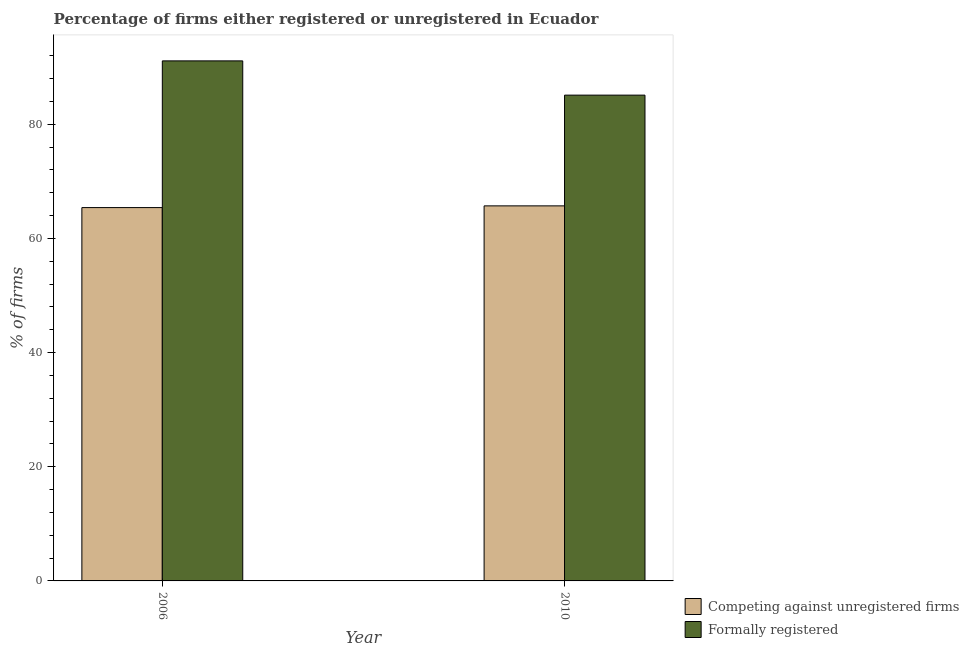How many groups of bars are there?
Keep it short and to the point. 2. How many bars are there on the 1st tick from the left?
Offer a very short reply. 2. How many bars are there on the 2nd tick from the right?
Give a very brief answer. 2. What is the label of the 1st group of bars from the left?
Your response must be concise. 2006. What is the percentage of registered firms in 2010?
Ensure brevity in your answer.  65.7. Across all years, what is the maximum percentage of registered firms?
Your answer should be very brief. 65.7. Across all years, what is the minimum percentage of formally registered firms?
Provide a succinct answer. 85.1. In which year was the percentage of registered firms minimum?
Give a very brief answer. 2006. What is the total percentage of formally registered firms in the graph?
Provide a short and direct response. 176.2. What is the difference between the percentage of registered firms in 2006 and that in 2010?
Give a very brief answer. -0.3. What is the difference between the percentage of registered firms in 2010 and the percentage of formally registered firms in 2006?
Your response must be concise. 0.3. What is the average percentage of registered firms per year?
Provide a succinct answer. 65.55. In the year 2010, what is the difference between the percentage of registered firms and percentage of formally registered firms?
Offer a very short reply. 0. What is the ratio of the percentage of registered firms in 2006 to that in 2010?
Your answer should be compact. 1. In how many years, is the percentage of formally registered firms greater than the average percentage of formally registered firms taken over all years?
Make the answer very short. 1. What does the 2nd bar from the left in 2006 represents?
Your response must be concise. Formally registered. What does the 2nd bar from the right in 2010 represents?
Make the answer very short. Competing against unregistered firms. How many bars are there?
Provide a short and direct response. 4. Are all the bars in the graph horizontal?
Make the answer very short. No. Are the values on the major ticks of Y-axis written in scientific E-notation?
Your response must be concise. No. Does the graph contain any zero values?
Provide a succinct answer. No. Does the graph contain grids?
Provide a succinct answer. No. How are the legend labels stacked?
Provide a short and direct response. Vertical. What is the title of the graph?
Your answer should be compact. Percentage of firms either registered or unregistered in Ecuador. What is the label or title of the Y-axis?
Give a very brief answer. % of firms. What is the % of firms in Competing against unregistered firms in 2006?
Your response must be concise. 65.4. What is the % of firms in Formally registered in 2006?
Give a very brief answer. 91.1. What is the % of firms in Competing against unregistered firms in 2010?
Provide a short and direct response. 65.7. What is the % of firms in Formally registered in 2010?
Your response must be concise. 85.1. Across all years, what is the maximum % of firms in Competing against unregistered firms?
Your answer should be compact. 65.7. Across all years, what is the maximum % of firms of Formally registered?
Ensure brevity in your answer.  91.1. Across all years, what is the minimum % of firms in Competing against unregistered firms?
Make the answer very short. 65.4. Across all years, what is the minimum % of firms in Formally registered?
Your answer should be compact. 85.1. What is the total % of firms in Competing against unregistered firms in the graph?
Make the answer very short. 131.1. What is the total % of firms of Formally registered in the graph?
Ensure brevity in your answer.  176.2. What is the difference between the % of firms of Competing against unregistered firms in 2006 and the % of firms of Formally registered in 2010?
Offer a very short reply. -19.7. What is the average % of firms in Competing against unregistered firms per year?
Offer a very short reply. 65.55. What is the average % of firms in Formally registered per year?
Give a very brief answer. 88.1. In the year 2006, what is the difference between the % of firms in Competing against unregistered firms and % of firms in Formally registered?
Your answer should be very brief. -25.7. In the year 2010, what is the difference between the % of firms in Competing against unregistered firms and % of firms in Formally registered?
Your answer should be very brief. -19.4. What is the ratio of the % of firms of Formally registered in 2006 to that in 2010?
Offer a very short reply. 1.07. What is the difference between the highest and the second highest % of firms in Formally registered?
Keep it short and to the point. 6. What is the difference between the highest and the lowest % of firms of Competing against unregistered firms?
Make the answer very short. 0.3. What is the difference between the highest and the lowest % of firms in Formally registered?
Your response must be concise. 6. 